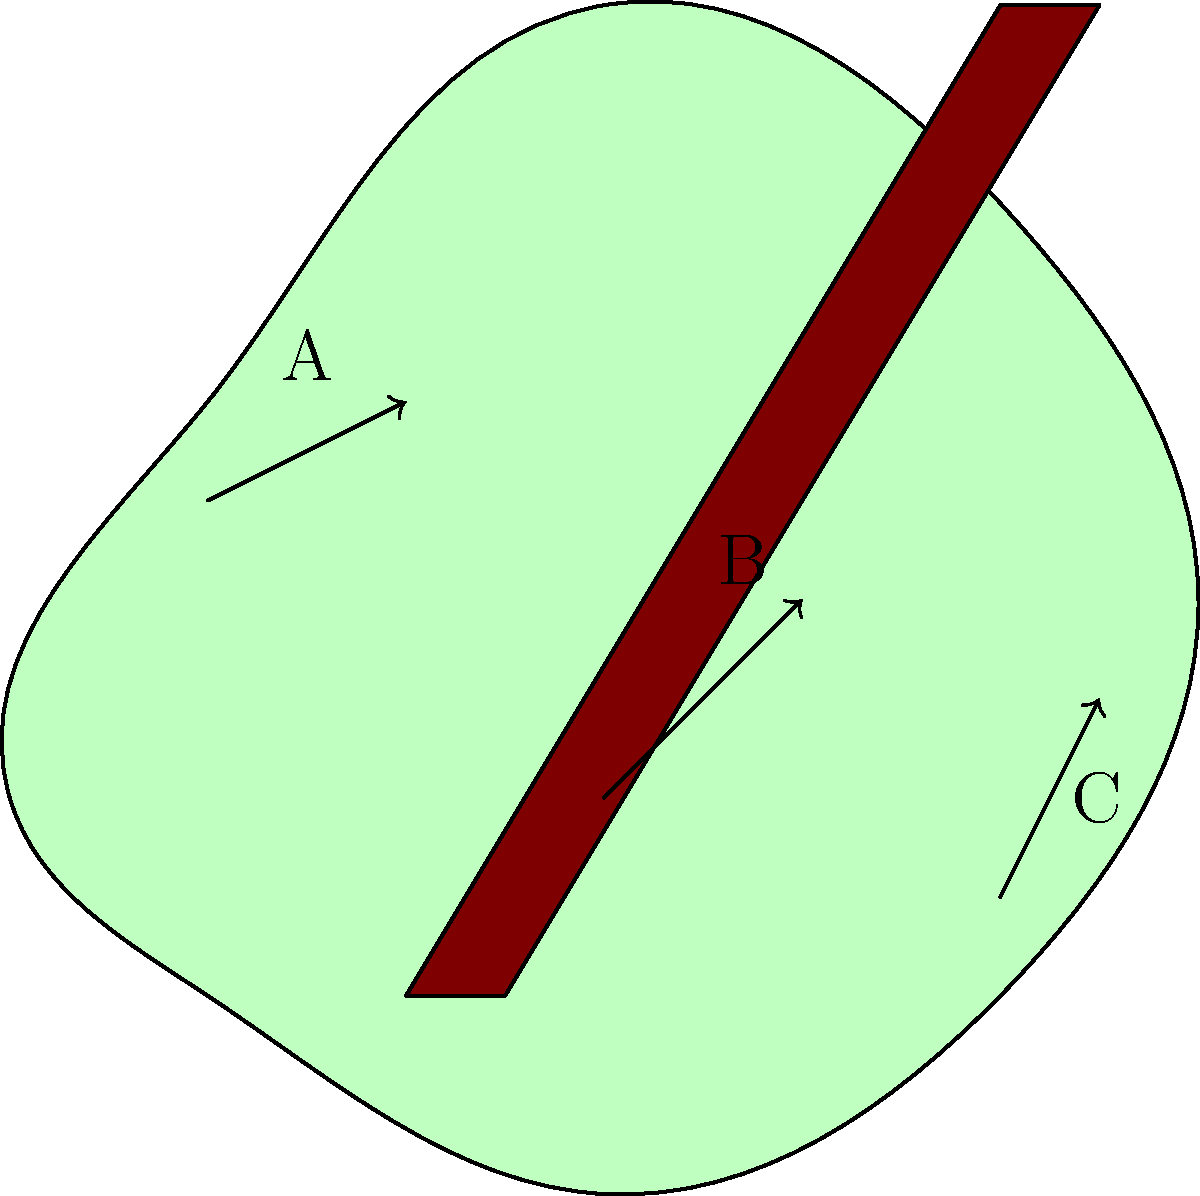As an auctioneer, which grip position on the gavel (A, B, or C) would likely provide the best balance between control and reduced strain during extended auction sessions? To determine the best grip position for an auctioneer's gavel, we need to consider ergonomics and biomechanics principles:

1. Position A (top of handle):
   - Offers maximum leverage for striking
   - Requires more wrist flexion, potentially leading to fatigue

2. Position B (middle of handle):
   - Provides a balance between leverage and control
   - Allows for a more neutral wrist position
   - Distributes force more evenly across the hand

3. Position C (bottom of handle):
   - Offers less leverage for striking
   - May require more effort to produce a loud, clear sound
   - Could lead to increased wrist extension

Considering these factors:

- Position B provides the best compromise between control and reduced strain.
- It allows for a more neutral wrist position, reducing the risk of repetitive strain injuries.
- The middle grip offers sufficient leverage for striking while maintaining control.
- Force distribution is more even, reducing fatigue during extended auction sessions.

Therefore, position B would likely be the most ergonomic and efficient choice for an auctioneer during long auction sessions.
Answer: Position B (middle of handle) 